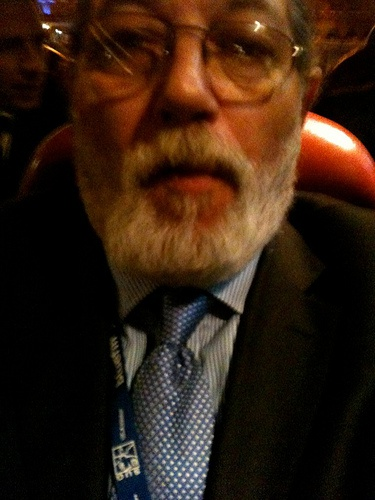Describe the objects in this image and their specific colors. I can see people in black, maroon, brown, and gray tones, tie in black, gray, and darkgray tones, people in black, maroon, and ivory tones, and chair in black, maroon, brown, and red tones in this image. 